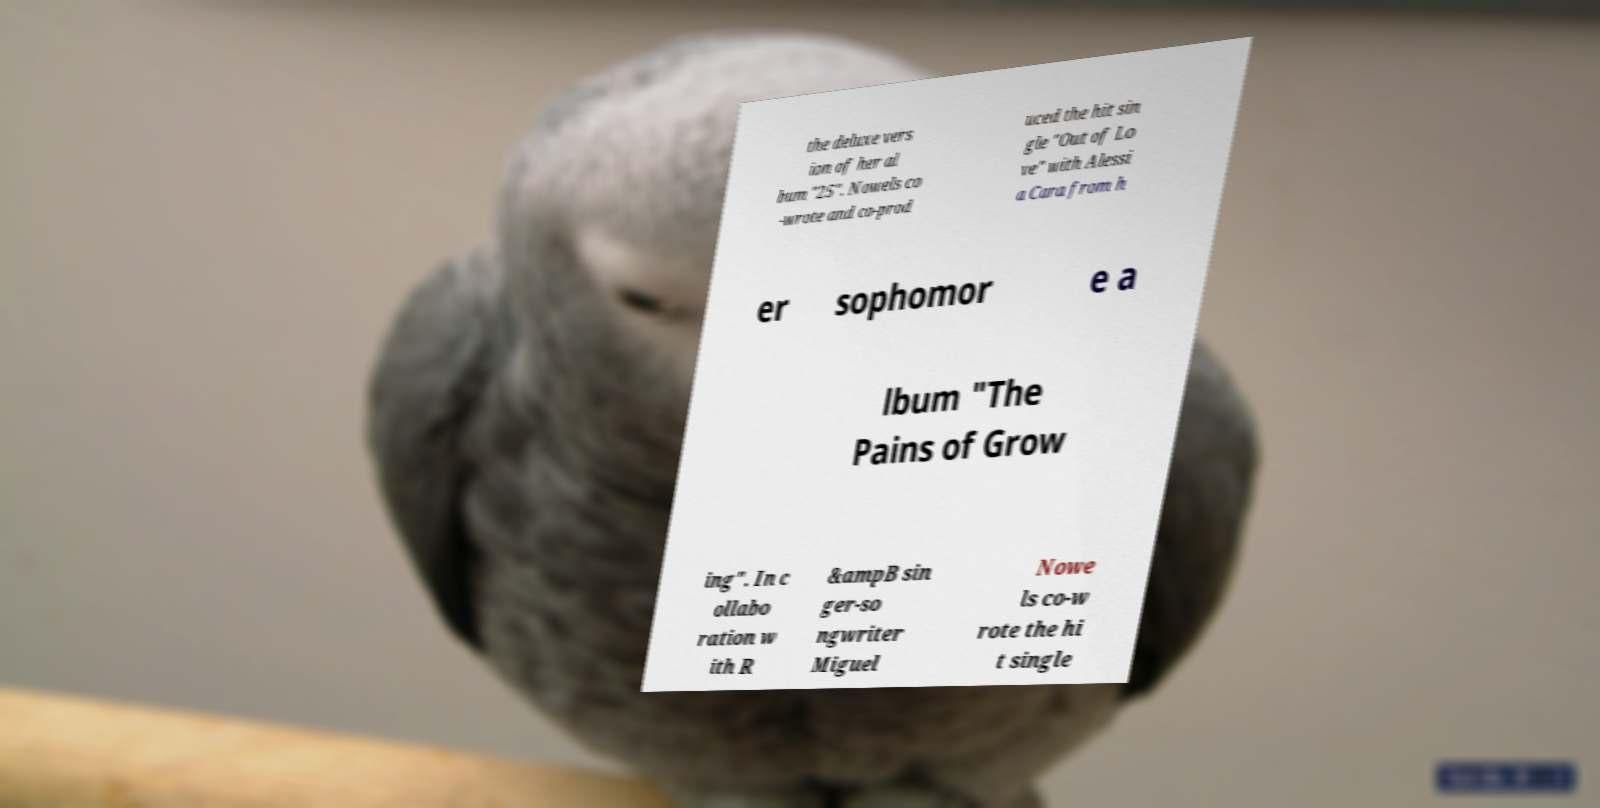Could you extract and type out the text from this image? the deluxe vers ion of her al bum "25". Nowels co -wrote and co-prod uced the hit sin gle "Out of Lo ve" with Alessi a Cara from h er sophomor e a lbum "The Pains of Grow ing". In c ollabo ration w ith R &ampB sin ger-so ngwriter Miguel Nowe ls co-w rote the hi t single 